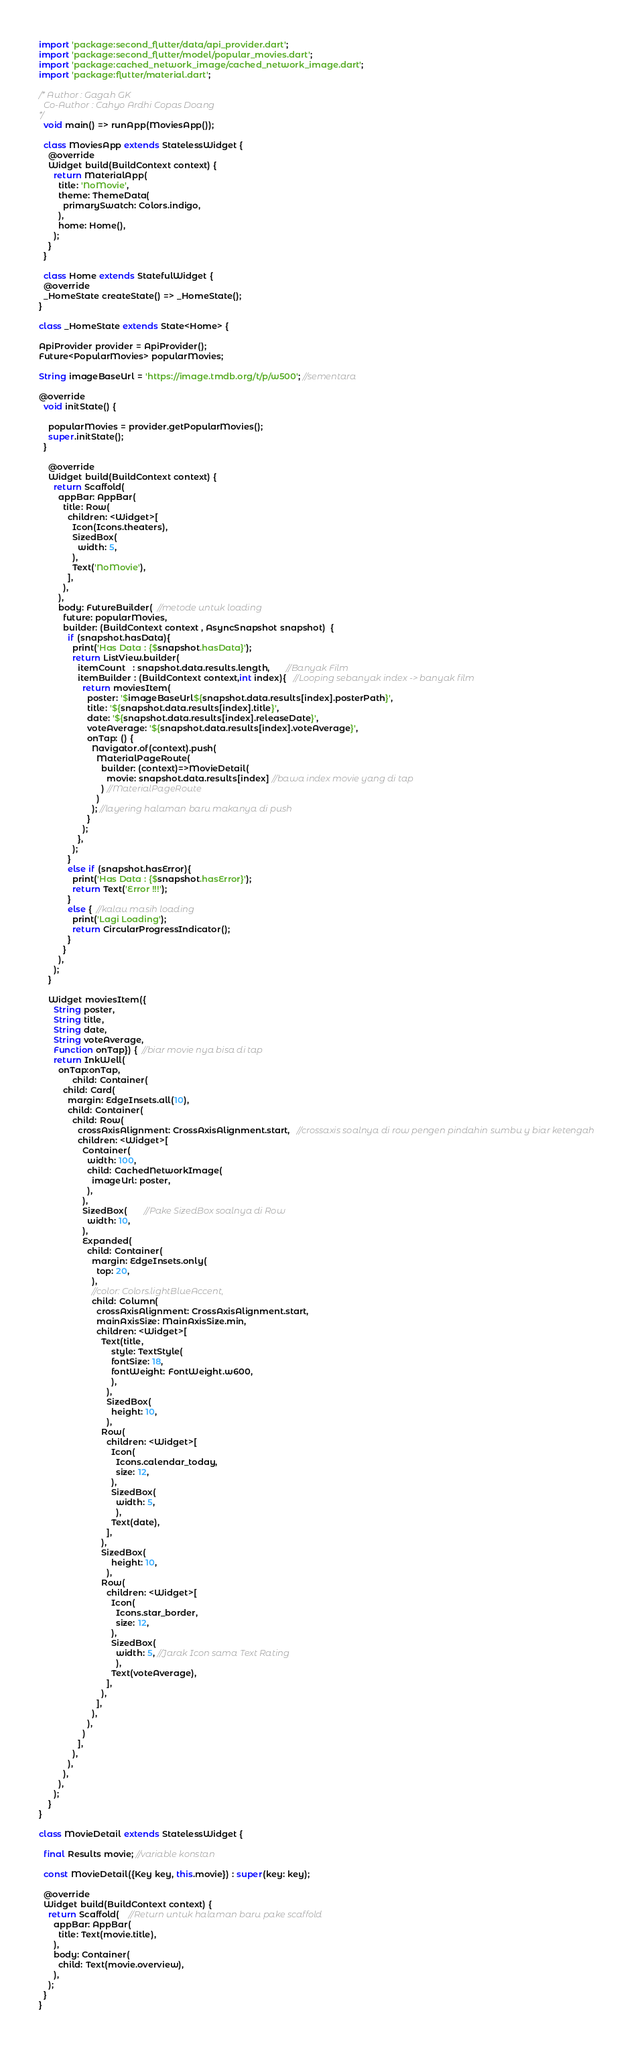Convert code to text. <code><loc_0><loc_0><loc_500><loc_500><_Dart_>import 'package:second_flutter/data/api_provider.dart';
import 'package:second_flutter/model/popular_movies.dart';
import 'package:cached_network_image/cached_network_image.dart';
import 'package:flutter/material.dart';

/* Author : Gagah GK
  Co-Author : Cahyo Ardhi Copas Doang
*/
  void main() => runApp(MoviesApp());

  class MoviesApp extends StatelessWidget {
    @override
    Widget build(BuildContext context) {
      return MaterialApp(
        title: 'NoMovie',
        theme: ThemeData(
          primarySwatch: Colors.indigo,
        ),
        home: Home(),
      );
    }
  }

  class Home extends StatefulWidget { 
  @override
  _HomeState createState() => _HomeState();
}

class _HomeState extends State<Home> {

ApiProvider provider = ApiProvider();
Future<PopularMovies> popularMovies;

String imageBaseUrl = 'https://image.tmdb.org/t/p/w500'; //sementara

@override
  void initState() {
    
    popularMovies = provider.getPopularMovies();
    super.initState();
  }

    @override
    Widget build(BuildContext context) {
      return Scaffold(
        appBar: AppBar(
          title: Row(
            children: <Widget>[
              Icon(Icons.theaters),
              SizedBox(
                width: 5,
              ),
              Text('NoMovie'),
            ],
          ),
        ),
        body: FutureBuilder(  //metode untuk loading
          future: popularMovies,
          builder: (BuildContext context , AsyncSnapshot snapshot)  {
            if (snapshot.hasData){
              print('Has Data : {$snapshot.hasData}');
              return ListView.builder(
                itemCount   : snapshot.data.results.length,       //Banyak Film
                itemBuilder : (BuildContext context,int index){   //Looping sebanyak index -> banyak film
                  return moviesItem(
                    poster: '$imageBaseUrl${snapshot.data.results[index].posterPath}',
                    title: '${snapshot.data.results[index].title}',
                    date: '${snapshot.data.results[index].releaseDate}',
                    voteAverage: '${snapshot.data.results[index].voteAverage}',
                    onTap: () {
                      Navigator.of(context).push(
                        MaterialPageRoute(
                          builder: (context)=>MovieDetail(
                            movie: snapshot.data.results[index] //bawa index movie yang di tap
                          ) //MaterialPageRoute
                        )
                      ); //layering halaman baru makanya di push
                    }
                  );
                },
              );
            }
            else if (snapshot.hasError){
              print('Has Data : {$snapshot.hasError}');
              return Text('Error !!!');
            }
            else {  //kalau masih loading
              print('Lagi Loading');
              return CircularProgressIndicator();
            }
          }
        ),
      );
    }

    Widget moviesItem({
      String poster, 
      String title, 
      String date,
      String voteAverage,
      Function onTap}) {  //biar movie nya bisa di tap
      return InkWell(
        onTap:onTap,
              child: Container(
          child: Card(
            margin: EdgeInsets.all(10),
            child: Container(
              child: Row(
                crossAxisAlignment: CrossAxisAlignment.start,   //crossaxis soalnya di row pengen pindahin sumbu y biar ketengah
                children: <Widget>[
                  Container(
                    width: 100,
                    child: CachedNetworkImage(
                      imageUrl: poster,
                    ),
                  ),
                  SizedBox(       //Pake SizedBox soalnya di Row
                    width: 10,
                  ),
                  Expanded(
                    child: Container(
                      margin: EdgeInsets.only(
                        top: 20,
                      ),
                      //color: Colors.lightBlueAccent,
                      child: Column(
                        crossAxisAlignment: CrossAxisAlignment.start,
                        mainAxisSize: MainAxisSize.min,
                        children: <Widget>[
                          Text(title, 
                              style: TextStyle(
                              fontSize: 18,
                              fontWeight: FontWeight.w600,
                              ),
                            ),
                            SizedBox(
                              height: 10,
                            ),
                          Row(
                            children: <Widget>[
                              Icon(
                                Icons.calendar_today,
                                size: 12,
                              ),
                              SizedBox(
                                width: 5,
                                ),
                              Text(date),
                            ],
                          ),
                          SizedBox(
                              height: 10,
                            ),
                          Row(
                            children: <Widget>[
                              Icon(
                                Icons.star_border,
                                size: 12,
                              ),
                              SizedBox(
                                width: 5, //Jarak Icon sama Text Rating
                                ),
                              Text(voteAverage),
                            ],
                          ),
                        ],
                      ),
                    ),
                  )
                ],
              ),
            ),
          ),
        ),
      );
    }
}

class MovieDetail extends StatelessWidget {

  final Results movie; //variable konstan

  const MovieDetail({Key key, this.movie}) : super(key: key); 

  @override
  Widget build(BuildContext context) {
    return Scaffold(    //Return untuk halaman baru pake scaffold
      appBar: AppBar(
        title: Text(movie.title),
      ),
      body: Container(
        child: Text(movie.overview),
      ),
    );
  }
}</code> 